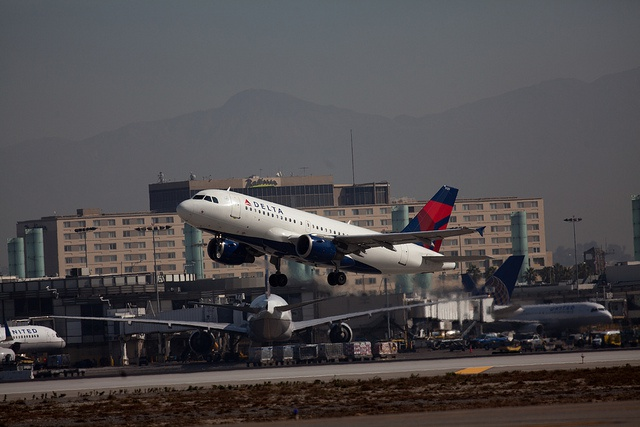Describe the objects in this image and their specific colors. I can see airplane in gray, black, lightgray, and darkgray tones, airplane in purple, black, gray, and darkgray tones, airplane in purple, black, gray, and darkgray tones, airplane in purple, black, darkgray, gray, and lightgray tones, and truck in purple, black, gray, and maroon tones in this image. 